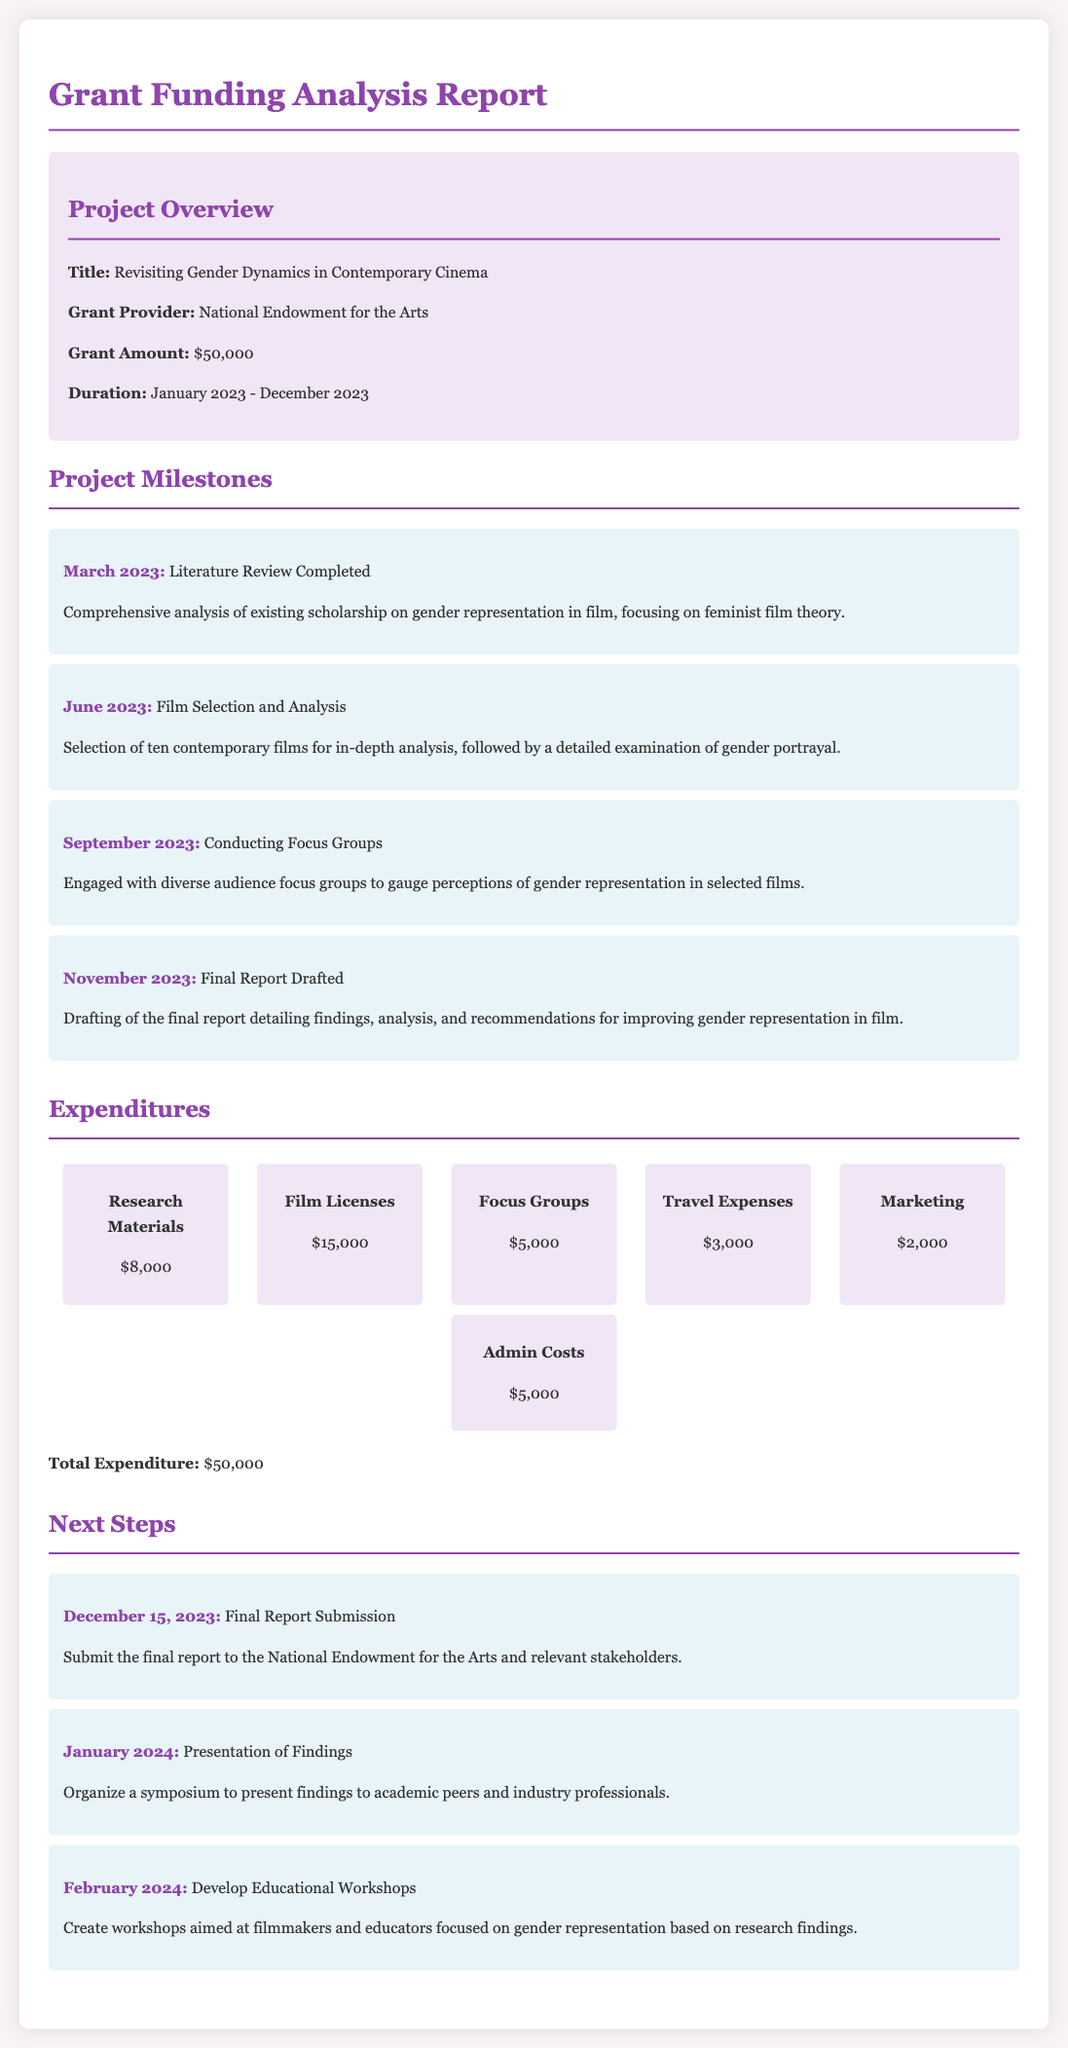what is the title of the project? The title of the project is mentioned in the project overview section of the document.
Answer: Revisiting Gender Dynamics in Contemporary Cinema who is the grant provider? The grant provider is listed in the project information section.
Answer: National Endowment for the Arts what is the total expenditure? The total expenditure is summarized in the expenditures section of the document.
Answer: $50,000 when was the literature review completed? The completion date for the literature review is provided in the milestones section.
Answer: March 2023 what were the total expenditures for film licenses? The expenditure for film licenses is specified in the expenditures section of the document.
Answer: $15,000 what is the focus of the educational workshops? The content of the educational workshops is indicated in the next steps section.
Answer: Gender representation based on research findings when is the final report due? The due date for the final report is stated in the next steps section.
Answer: December 15, 2023 how many films were selected for analysis? The number of films selected for analysis is mentioned in the milestones section.
Answer: Ten what was the expenditure for focus groups? The expenditure for focus groups is detailed in the expenditures section.
Answer: $5,000 